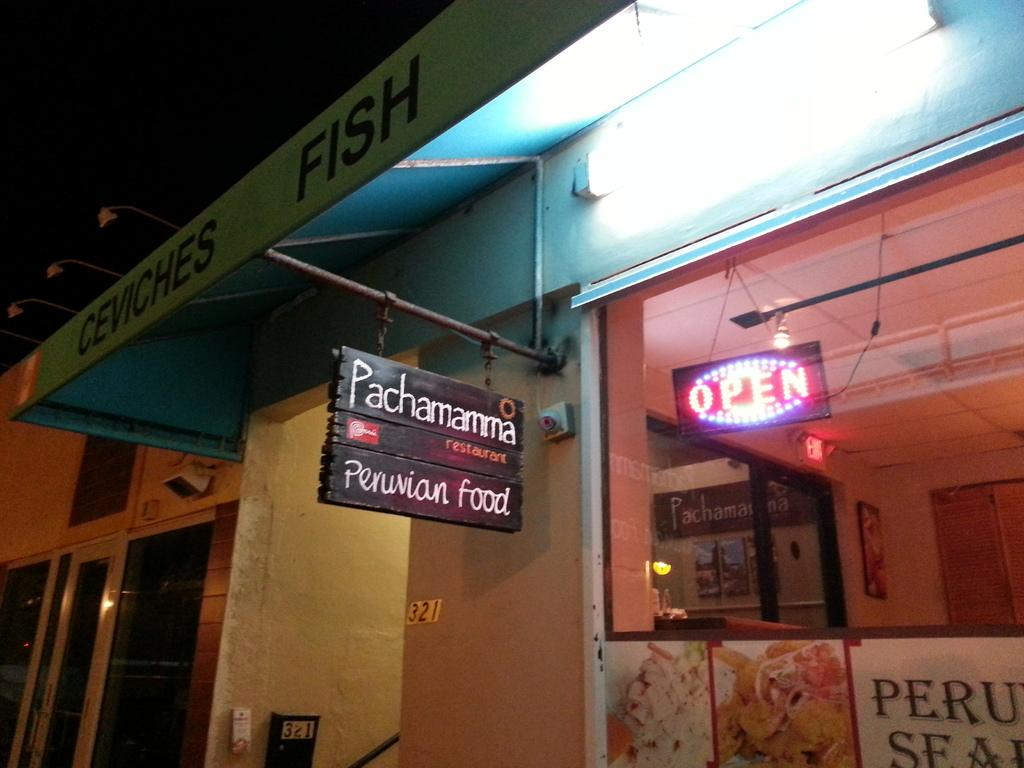<image>
Describe the image concisely. A neon open sign in the window of a Peruvian Restaurant 